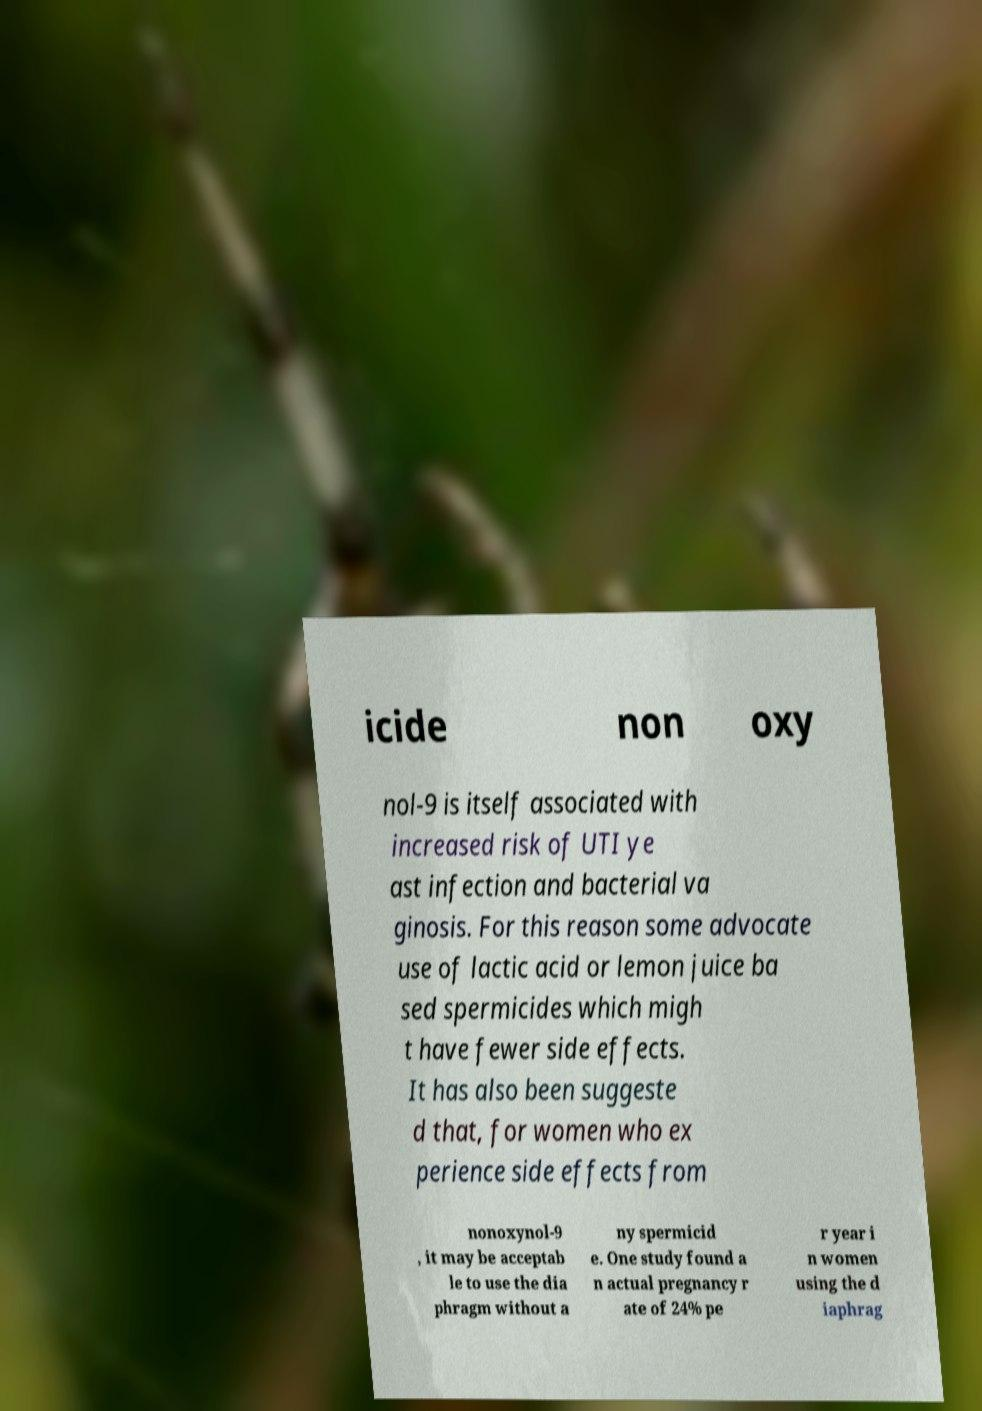Can you accurately transcribe the text from the provided image for me? icide non oxy nol-9 is itself associated with increased risk of UTI ye ast infection and bacterial va ginosis. For this reason some advocate use of lactic acid or lemon juice ba sed spermicides which migh t have fewer side effects. It has also been suggeste d that, for women who ex perience side effects from nonoxynol-9 , it may be acceptab le to use the dia phragm without a ny spermicid e. One study found a n actual pregnancy r ate of 24% pe r year i n women using the d iaphrag 